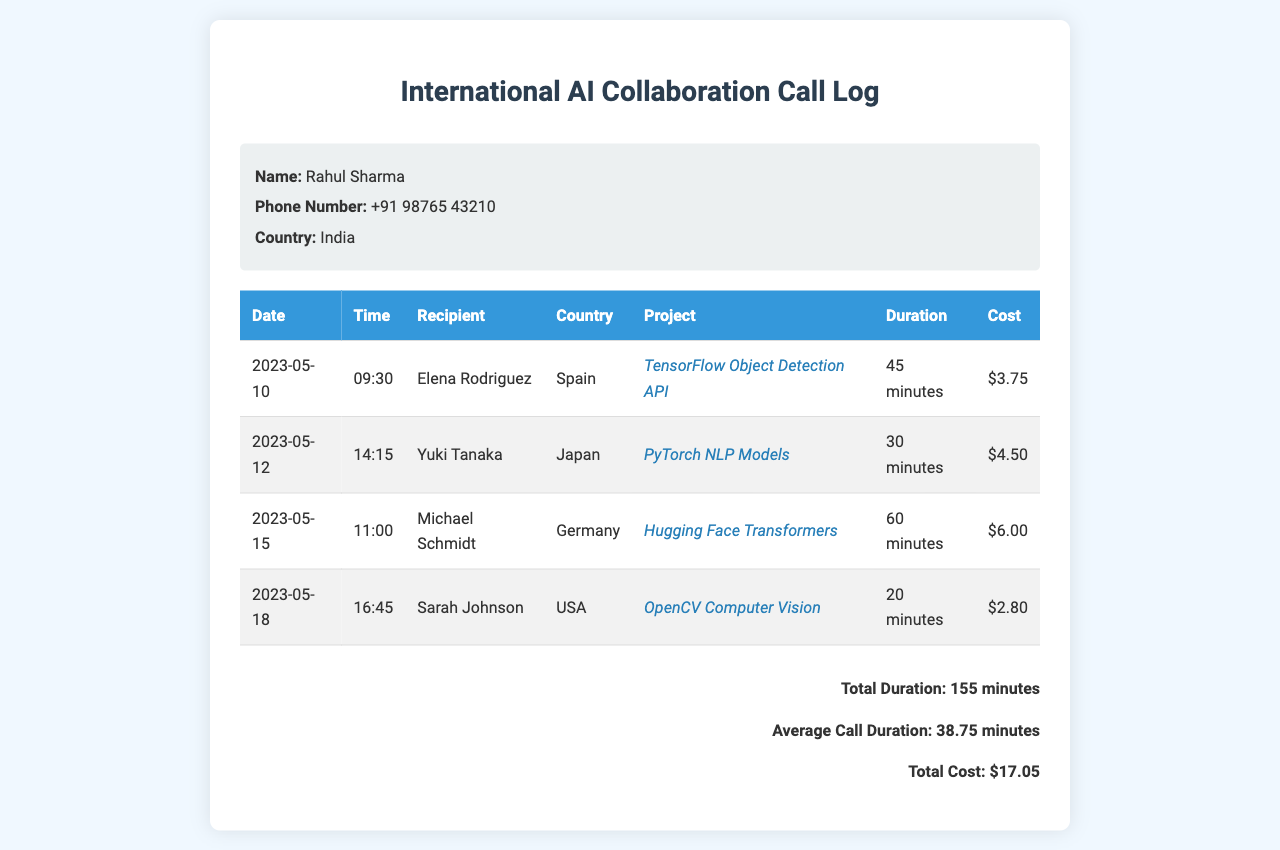What is the name of the caller? The caller's name is provided in the personal info section of the document.
Answer: Rahul Sharma What was the duration of the call to Yuki Tanaka? The duration of the call is listed in the records table under the respective entry for Yuki Tanaka.
Answer: 30 minutes Which country did Sarah Johnson call from? The country of the call recipient is specified in the table corresponding to Sarah Johnson.
Answer: USA What is the total cost of the calls made? The total cost is summarized at the end of the document, detailing all call costs combined.
Answer: $17.05 What is the average call duration? The average call duration is calculated and mentioned in the summary section of the document.
Answer: 38.75 minutes What project was discussed in the call with Michael Schmidt? The corresponding project is noted in the records table for that specific call.
Answer: Hugging Face Transformers How many minutes of calls were made in total? The total duration is summarized at the end of the document, aggregating all minutes.
Answer: 155 minutes Which date had the longest call duration? The date with the longest call can be identified by reviewing the duration in the table.
Answer: 2023-05-15 Who is the call recipient from Germany? The recipient name is identified in the table next to the respective country and date.
Answer: Michael Schmidt 